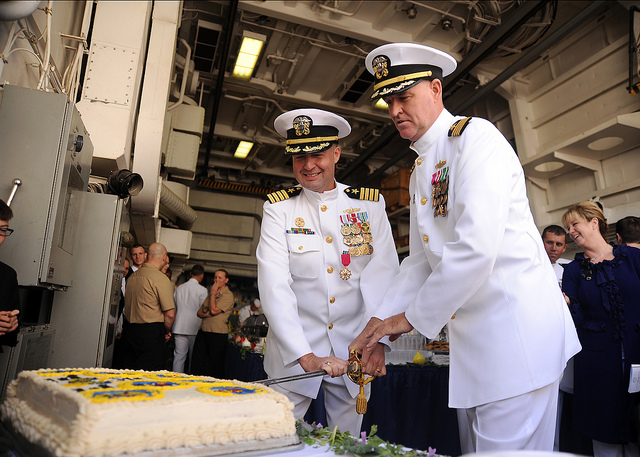<image>Is this a retirement or going away party? It is unknown whether this is a retirement or going away party as it is not explicitly shown in the image. What team is on the man's hat? I don't know what team is on the man's hat. It can be seen 'navy' or 'none'. Is this a retirement or going away party? It is unknown whether this is a retirement or going away party. What team is on the man's hat? I am not sure what team is on the man's hat. It can be seen 'navy' or 'none'. 